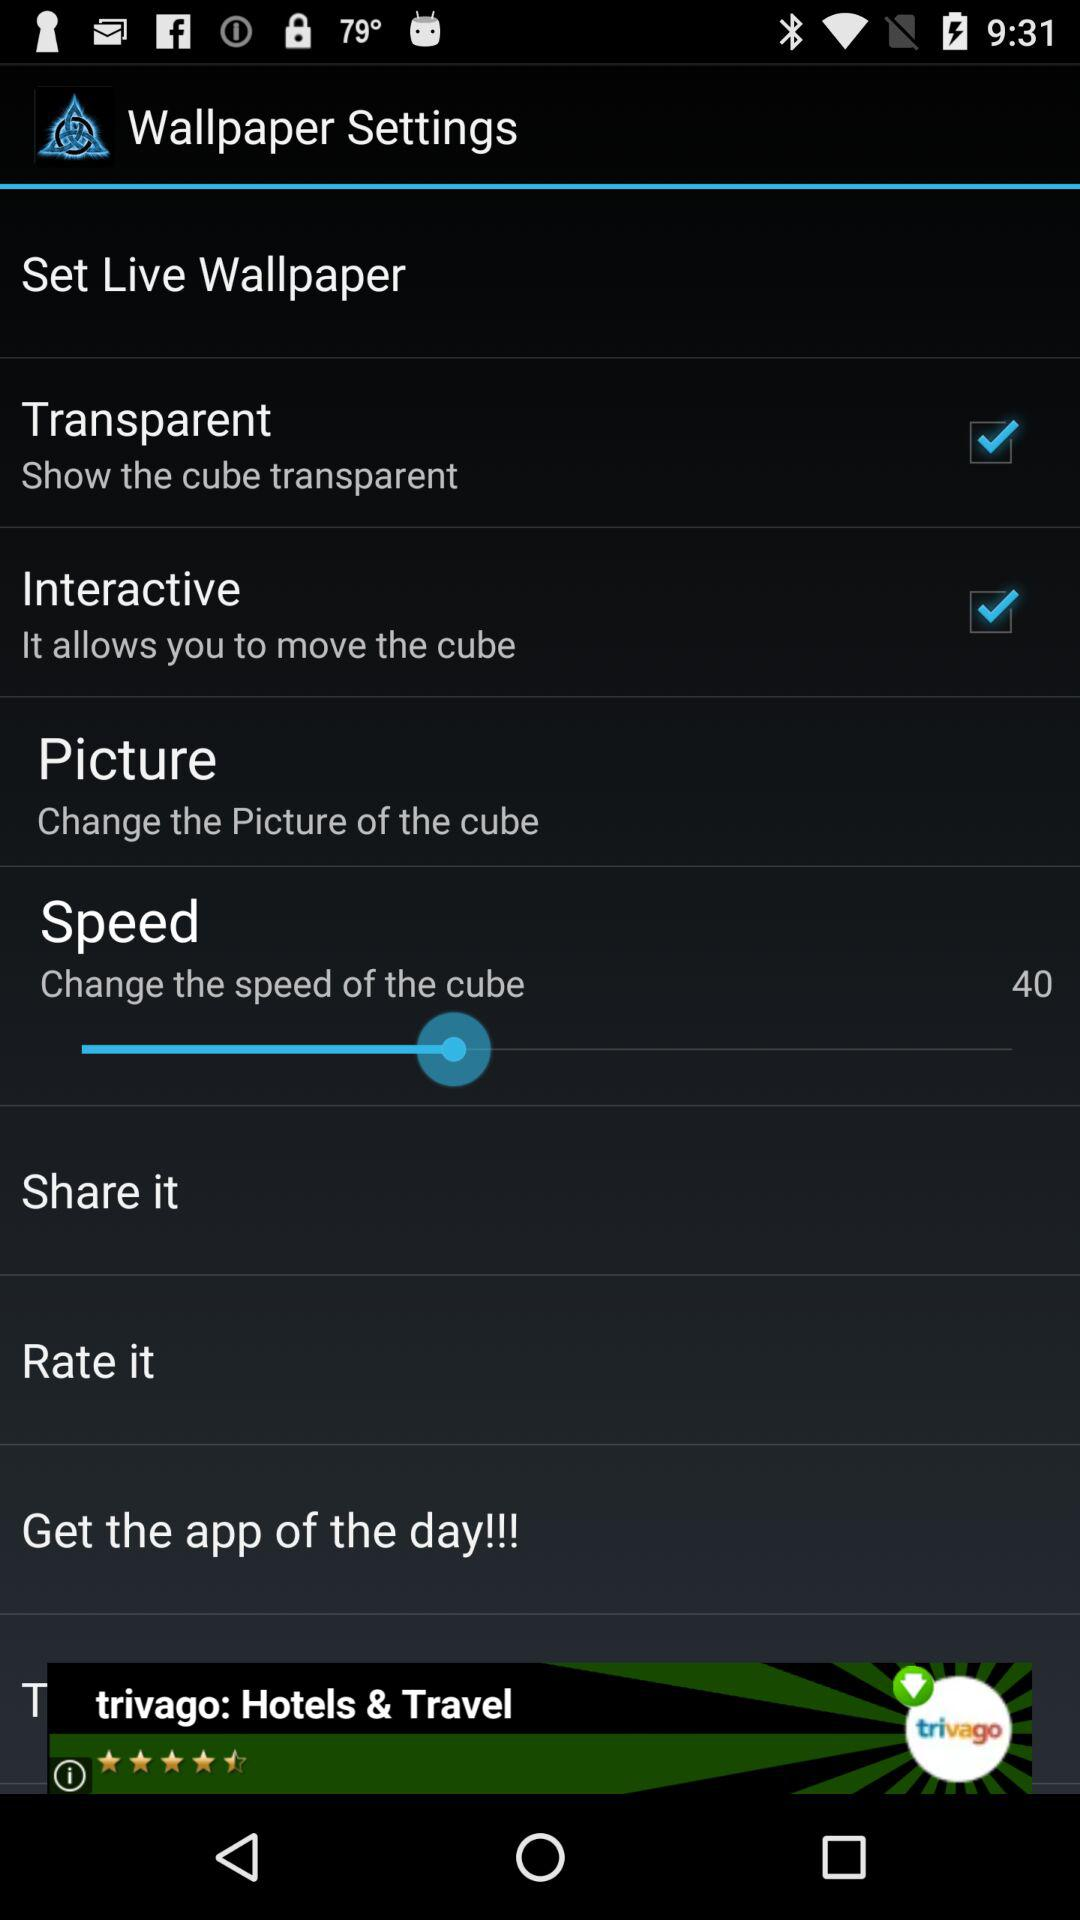What is the status of "Interactive"? The status is "on". 